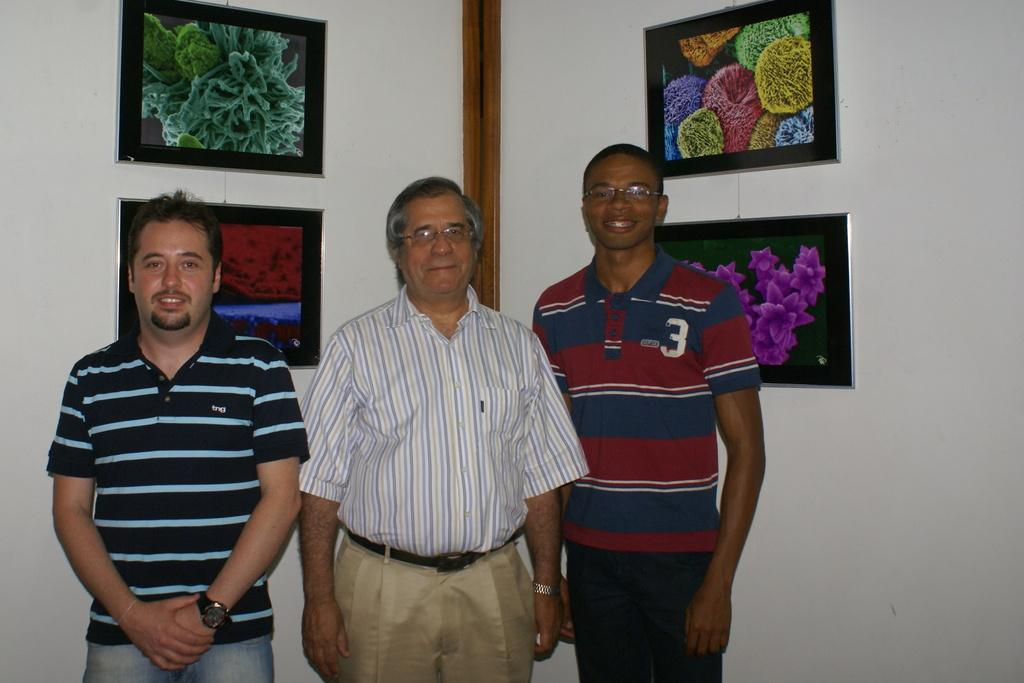How many people are in the image? There are three persons in the image. What are the expressions on the faces of the people in the image? The persons are standing with smiles on their faces. What can be seen in the background of the image? There are frames hanging on the wall in the background of the image. What type of train can be seen passing by in the image? There is no train present in the image. Is there a garden visible in the background of the image? The background of the image does not show a garden; it only shows frames hanging on the wall. 